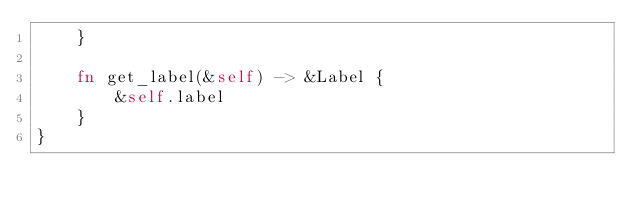Convert code to text. <code><loc_0><loc_0><loc_500><loc_500><_Rust_>    }

    fn get_label(&self) -> &Label {
        &self.label
    }
}
</code> 